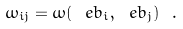<formula> <loc_0><loc_0><loc_500><loc_500>\omega _ { i j } = \omega ( \ e b _ { i } , \ e b _ { j } ) \ .</formula> 